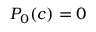<formula> <loc_0><loc_0><loc_500><loc_500>P _ { 0 } ( c ) = 0</formula> 